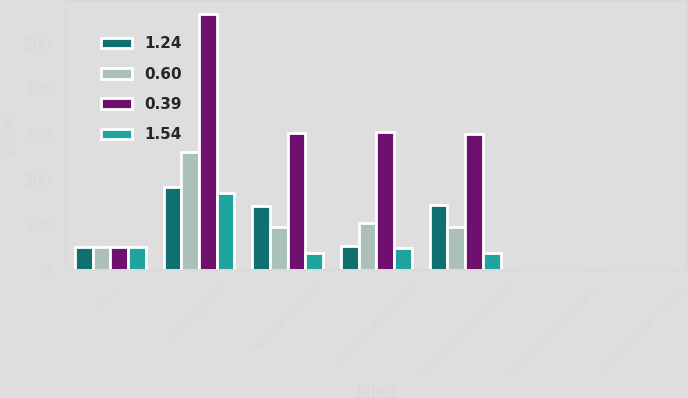Convert chart. <chart><loc_0><loc_0><loc_500><loc_500><stacked_bar_chart><ecel><fcel>Ameren<fcel>Operating income<fcel>Net income (loss) (b)<fcel>Net income attributable to<fcel>Net income (loss) attributable<fcel>Earnings per common share -<fcel>Earnings (loss) per common<nl><fcel>1.24<fcel>51<fcel>185<fcel>143<fcel>54<fcel>145<fcel>0.22<fcel>0.82<nl><fcel>0.6<fcel>51<fcel>261<fcel>96<fcel>105<fcel>95<fcel>0.44<fcel>0.05<nl><fcel>0.39<fcel>51<fcel>567<fcel>304<fcel>305<fcel>302<fcel>1.26<fcel>0.01<nl><fcel>1.54<fcel>51<fcel>171<fcel>38<fcel>48<fcel>37<fcel>0.19<fcel>0.04<nl></chart> 